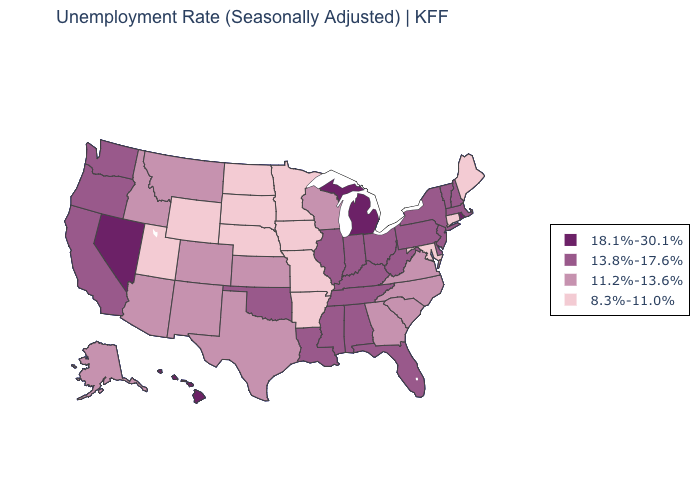Among the states that border South Dakota , which have the highest value?
Quick response, please. Montana. What is the highest value in the USA?
Be succinct. 18.1%-30.1%. How many symbols are there in the legend?
Quick response, please. 4. What is the lowest value in the USA?
Give a very brief answer. 8.3%-11.0%. Does Colorado have the highest value in the USA?
Concise answer only. No. Name the states that have a value in the range 8.3%-11.0%?
Give a very brief answer. Arkansas, Connecticut, Iowa, Maine, Maryland, Minnesota, Missouri, Nebraska, North Dakota, South Dakota, Utah, Wyoming. What is the value of Virginia?
Give a very brief answer. 11.2%-13.6%. Does the map have missing data?
Give a very brief answer. No. Among the states that border Maryland , does West Virginia have the highest value?
Concise answer only. Yes. What is the highest value in the West ?
Give a very brief answer. 18.1%-30.1%. Which states have the lowest value in the USA?
Write a very short answer. Arkansas, Connecticut, Iowa, Maine, Maryland, Minnesota, Missouri, Nebraska, North Dakota, South Dakota, Utah, Wyoming. Name the states that have a value in the range 13.8%-17.6%?
Write a very short answer. Alabama, California, Delaware, Florida, Illinois, Indiana, Kentucky, Louisiana, Massachusetts, Mississippi, New Hampshire, New Jersey, New York, Ohio, Oklahoma, Oregon, Pennsylvania, Tennessee, Vermont, Washington, West Virginia. Which states hav the highest value in the Northeast?
Be succinct. Rhode Island. What is the value of Wyoming?
Quick response, please. 8.3%-11.0%. Does Vermont have the same value as Delaware?
Answer briefly. Yes. 